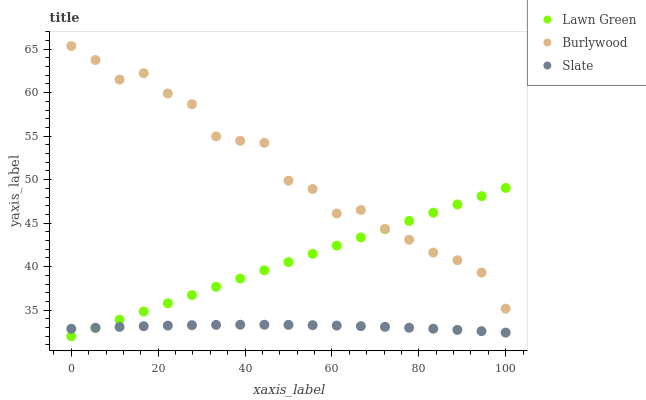Does Slate have the minimum area under the curve?
Answer yes or no. Yes. Does Burlywood have the maximum area under the curve?
Answer yes or no. Yes. Does Lawn Green have the minimum area under the curve?
Answer yes or no. No. Does Lawn Green have the maximum area under the curve?
Answer yes or no. No. Is Lawn Green the smoothest?
Answer yes or no. Yes. Is Burlywood the roughest?
Answer yes or no. Yes. Is Slate the smoothest?
Answer yes or no. No. Is Slate the roughest?
Answer yes or no. No. Does Lawn Green have the lowest value?
Answer yes or no. Yes. Does Slate have the lowest value?
Answer yes or no. No. Does Burlywood have the highest value?
Answer yes or no. Yes. Does Lawn Green have the highest value?
Answer yes or no. No. Is Slate less than Burlywood?
Answer yes or no. Yes. Is Burlywood greater than Slate?
Answer yes or no. Yes. Does Burlywood intersect Lawn Green?
Answer yes or no. Yes. Is Burlywood less than Lawn Green?
Answer yes or no. No. Is Burlywood greater than Lawn Green?
Answer yes or no. No. Does Slate intersect Burlywood?
Answer yes or no. No. 